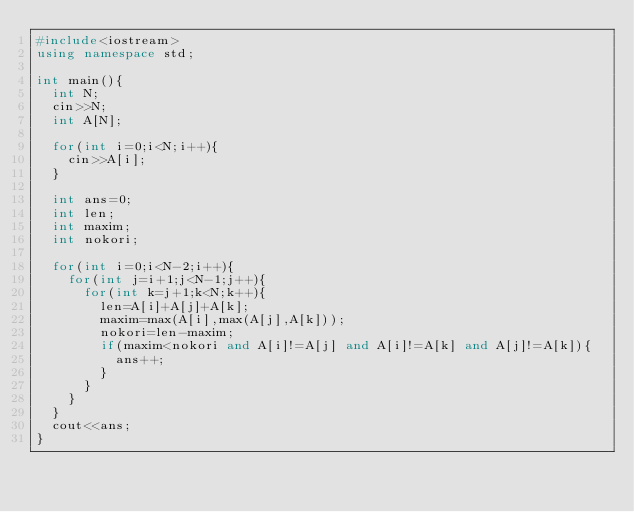<code> <loc_0><loc_0><loc_500><loc_500><_C++_>#include<iostream>
using namespace std;

int main(){
  int N;
  cin>>N;
  int A[N];
  
  for(int i=0;i<N;i++){
    cin>>A[i];
  }
  
  int ans=0;
  int len;
  int maxim;
  int nokori;
  
  for(int i=0;i<N-2;i++){
    for(int j=i+1;j<N-1;j++){
      for(int k=j+1;k<N;k++){
        len=A[i]+A[j]+A[k];
        maxim=max(A[i],max(A[j],A[k]));
        nokori=len-maxim;
        if(maxim<nokori and A[i]!=A[j] and A[i]!=A[k] and A[j]!=A[k]){
          ans++;
        }
      }
    }
  }
  cout<<ans;
}
        
      </code> 